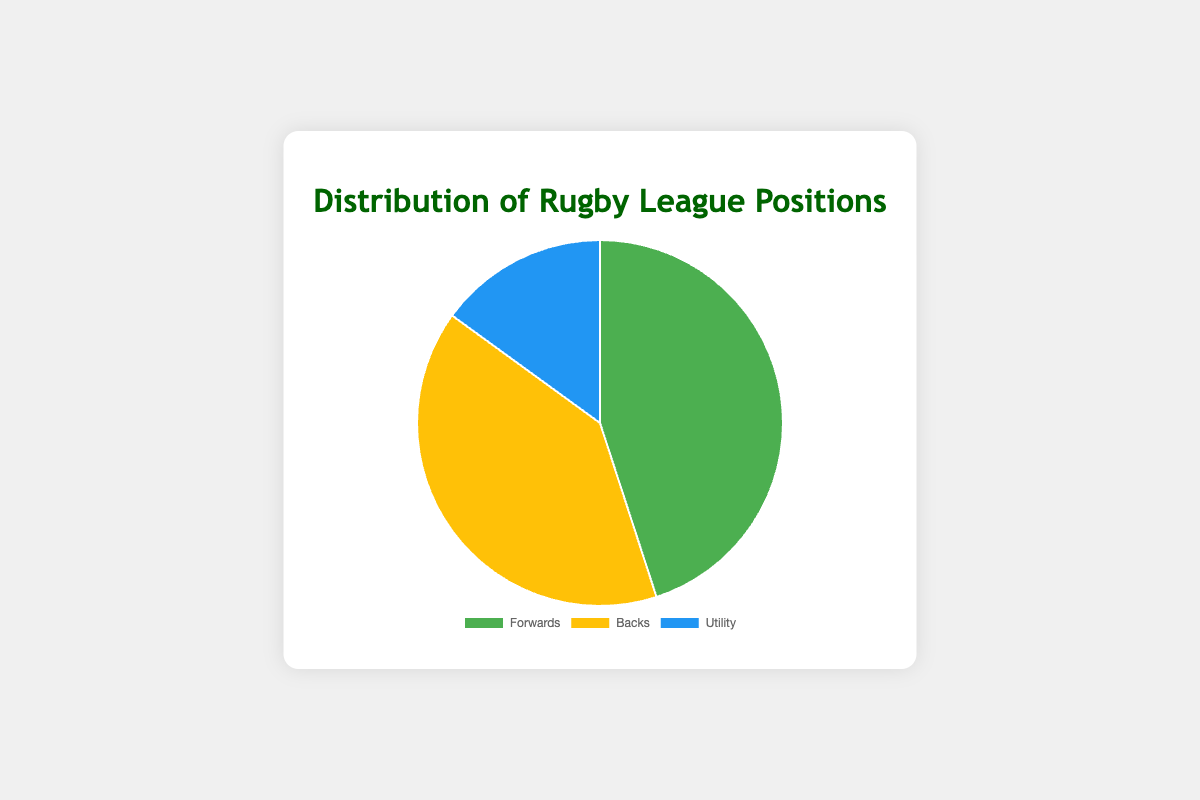Which rugby league position has the highest percentage of players? Forwards have the highest percentage of players at 45%, which is visually the largest section of the pie chart.
Answer: Forwards Which two rugby league positions combined account for more than 50% of the players? Both Forwards and Backs together sum up to 45% + 40% = 85%, which is more than 50%.
Answer: Forwards and Backs Which position has the smallest proportion of players and what is its percentage? The Utility position has the smallest section in the pie chart, which represents 15%.
Answer: Utility, 15% Is the percentage of Forwards more than the combined percentage of Backs and Utility players? The combined percentage of Backs and Utility is 40% + 15% = 55%, which is greater than the percentage of Forwards at 45%.
Answer: No What is the difference in percentage between the Forwards and the Backs? Forwards have 45% and Backs have 40%. The difference is 45% - 40% = 5%.
Answer: 5% Which position(s) together make up exactly 55% of the players? Backs and Utility together sum up to 40% + 15% = 55%.
Answer: Backs and Utility How much larger is the section for Forwards compared to Utility in terms of percentage points? Forwards have 45% and Utility has 15%. The difference is 45% - 15% = 30 percentage points.
Answer: 30 percentage points Which position's section is visually closest in size to the section for Forwards? The section for Backs is closest in size to Forwards, with Backs at 40% and Forwards at 45%.
Answer: Backs 